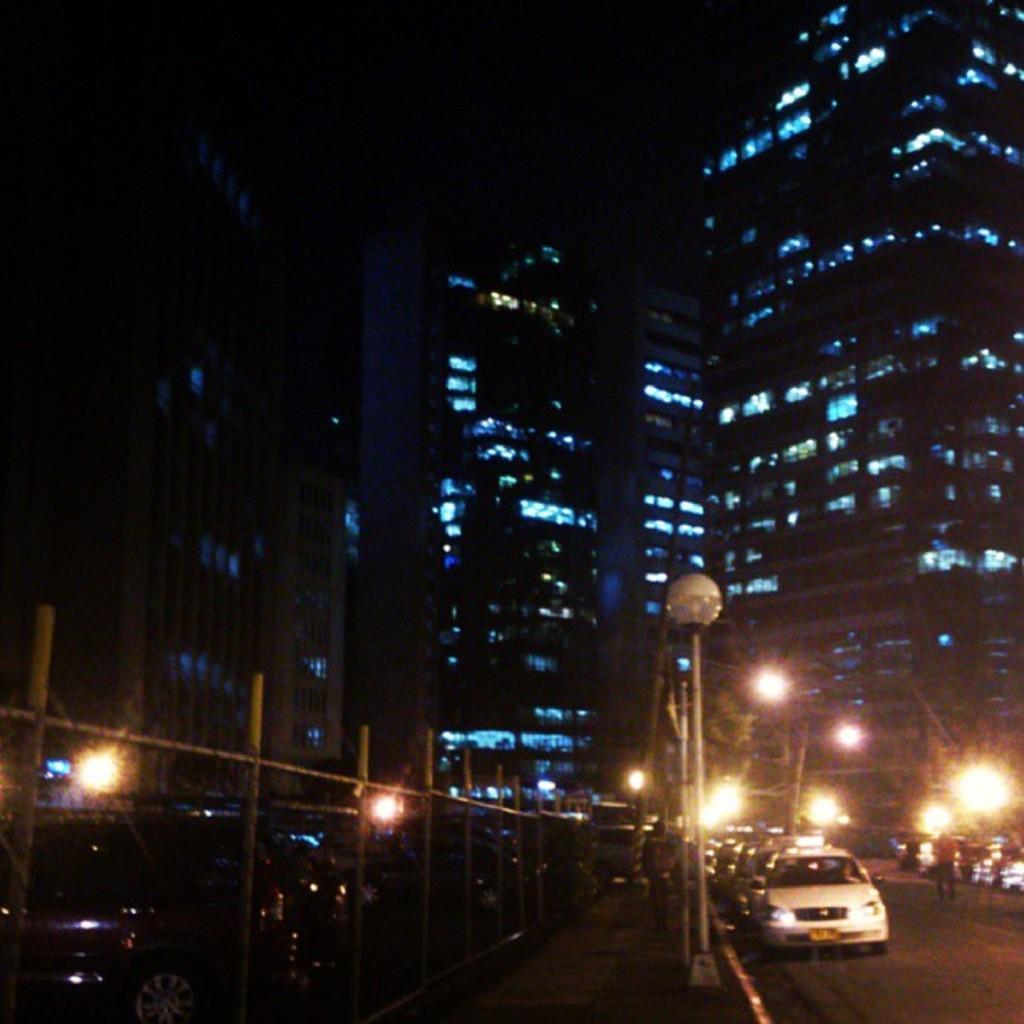Could you give a brief overview of what you see in this image? This image is taken outdoors. In the background there are a few buildings and there are a few lights. At the bottom of the image there is a road. In the middle of the image there are a few poles with street lights and many cars are parked on the road and there is a railing. 